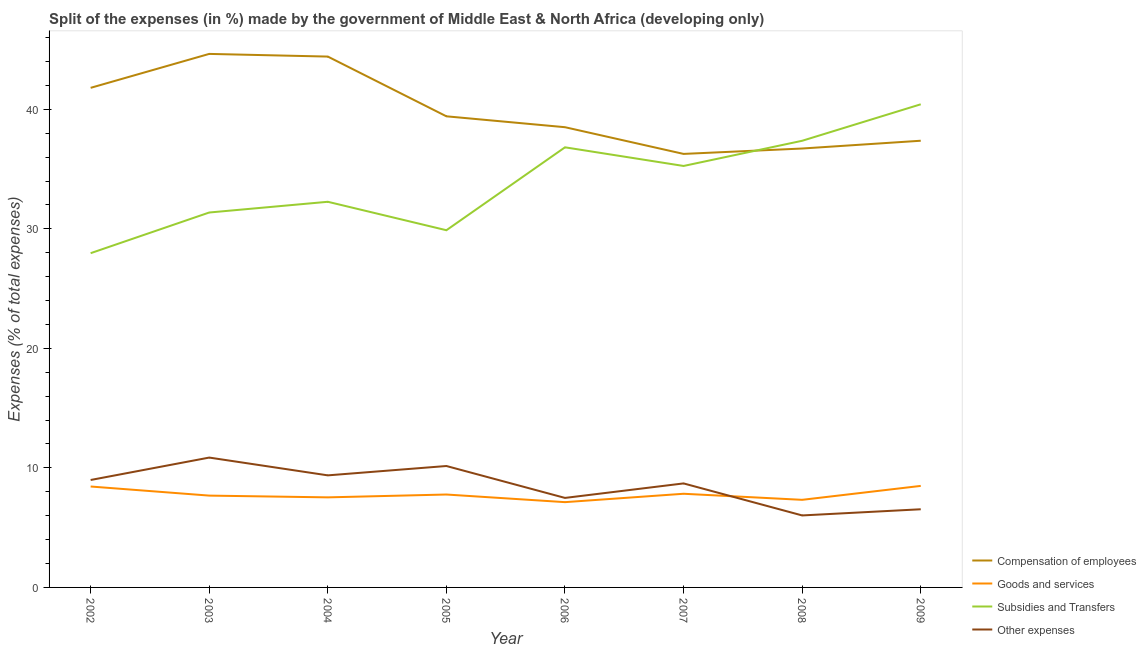Does the line corresponding to percentage of amount spent on goods and services intersect with the line corresponding to percentage of amount spent on subsidies?
Ensure brevity in your answer.  No. What is the percentage of amount spent on compensation of employees in 2006?
Your response must be concise. 38.5. Across all years, what is the maximum percentage of amount spent on other expenses?
Offer a very short reply. 10.86. Across all years, what is the minimum percentage of amount spent on other expenses?
Provide a succinct answer. 6.02. What is the total percentage of amount spent on goods and services in the graph?
Your answer should be compact. 62.23. What is the difference between the percentage of amount spent on goods and services in 2004 and that in 2009?
Give a very brief answer. -0.96. What is the difference between the percentage of amount spent on subsidies in 2002 and the percentage of amount spent on goods and services in 2005?
Make the answer very short. 20.19. What is the average percentage of amount spent on subsidies per year?
Make the answer very short. 33.92. In the year 2002, what is the difference between the percentage of amount spent on subsidies and percentage of amount spent on goods and services?
Provide a succinct answer. 19.52. What is the ratio of the percentage of amount spent on subsidies in 2007 to that in 2008?
Offer a very short reply. 0.94. Is the percentage of amount spent on goods and services in 2002 less than that in 2003?
Your answer should be compact. No. Is the difference between the percentage of amount spent on other expenses in 2002 and 2007 greater than the difference between the percentage of amount spent on subsidies in 2002 and 2007?
Ensure brevity in your answer.  Yes. What is the difference between the highest and the second highest percentage of amount spent on subsidies?
Ensure brevity in your answer.  3.05. What is the difference between the highest and the lowest percentage of amount spent on subsidies?
Provide a short and direct response. 12.46. Does the percentage of amount spent on compensation of employees monotonically increase over the years?
Ensure brevity in your answer.  No. Is the percentage of amount spent on other expenses strictly less than the percentage of amount spent on subsidies over the years?
Provide a succinct answer. Yes. How many lines are there?
Provide a succinct answer. 4. Where does the legend appear in the graph?
Keep it short and to the point. Bottom right. How many legend labels are there?
Offer a very short reply. 4. How are the legend labels stacked?
Give a very brief answer. Vertical. What is the title of the graph?
Provide a succinct answer. Split of the expenses (in %) made by the government of Middle East & North Africa (developing only). What is the label or title of the X-axis?
Give a very brief answer. Year. What is the label or title of the Y-axis?
Offer a terse response. Expenses (% of total expenses). What is the Expenses (% of total expenses) of Compensation of employees in 2002?
Your response must be concise. 41.8. What is the Expenses (% of total expenses) of Goods and services in 2002?
Offer a terse response. 8.44. What is the Expenses (% of total expenses) in Subsidies and Transfers in 2002?
Provide a short and direct response. 27.96. What is the Expenses (% of total expenses) in Other expenses in 2002?
Provide a short and direct response. 8.99. What is the Expenses (% of total expenses) of Compensation of employees in 2003?
Keep it short and to the point. 44.64. What is the Expenses (% of total expenses) in Goods and services in 2003?
Your answer should be compact. 7.68. What is the Expenses (% of total expenses) in Subsidies and Transfers in 2003?
Give a very brief answer. 31.37. What is the Expenses (% of total expenses) in Other expenses in 2003?
Your answer should be compact. 10.86. What is the Expenses (% of total expenses) of Compensation of employees in 2004?
Keep it short and to the point. 44.41. What is the Expenses (% of total expenses) of Goods and services in 2004?
Your response must be concise. 7.54. What is the Expenses (% of total expenses) of Subsidies and Transfers in 2004?
Provide a short and direct response. 32.26. What is the Expenses (% of total expenses) in Other expenses in 2004?
Give a very brief answer. 9.38. What is the Expenses (% of total expenses) of Compensation of employees in 2005?
Provide a succinct answer. 39.41. What is the Expenses (% of total expenses) of Goods and services in 2005?
Offer a very short reply. 7.77. What is the Expenses (% of total expenses) in Subsidies and Transfers in 2005?
Provide a short and direct response. 29.88. What is the Expenses (% of total expenses) in Other expenses in 2005?
Ensure brevity in your answer.  10.16. What is the Expenses (% of total expenses) in Compensation of employees in 2006?
Your answer should be compact. 38.5. What is the Expenses (% of total expenses) of Goods and services in 2006?
Make the answer very short. 7.13. What is the Expenses (% of total expenses) in Subsidies and Transfers in 2006?
Your answer should be very brief. 36.82. What is the Expenses (% of total expenses) of Other expenses in 2006?
Offer a very short reply. 7.49. What is the Expenses (% of total expenses) in Compensation of employees in 2007?
Keep it short and to the point. 36.27. What is the Expenses (% of total expenses) in Goods and services in 2007?
Your answer should be compact. 7.84. What is the Expenses (% of total expenses) of Subsidies and Transfers in 2007?
Your answer should be very brief. 35.26. What is the Expenses (% of total expenses) of Other expenses in 2007?
Your response must be concise. 8.7. What is the Expenses (% of total expenses) of Compensation of employees in 2008?
Make the answer very short. 36.72. What is the Expenses (% of total expenses) in Goods and services in 2008?
Your answer should be compact. 7.33. What is the Expenses (% of total expenses) of Subsidies and Transfers in 2008?
Provide a succinct answer. 37.37. What is the Expenses (% of total expenses) in Other expenses in 2008?
Your answer should be very brief. 6.02. What is the Expenses (% of total expenses) of Compensation of employees in 2009?
Offer a very short reply. 37.37. What is the Expenses (% of total expenses) of Goods and services in 2009?
Give a very brief answer. 8.49. What is the Expenses (% of total expenses) in Subsidies and Transfers in 2009?
Give a very brief answer. 40.42. What is the Expenses (% of total expenses) of Other expenses in 2009?
Your answer should be very brief. 6.54. Across all years, what is the maximum Expenses (% of total expenses) in Compensation of employees?
Your answer should be very brief. 44.64. Across all years, what is the maximum Expenses (% of total expenses) of Goods and services?
Make the answer very short. 8.49. Across all years, what is the maximum Expenses (% of total expenses) of Subsidies and Transfers?
Make the answer very short. 40.42. Across all years, what is the maximum Expenses (% of total expenses) in Other expenses?
Provide a short and direct response. 10.86. Across all years, what is the minimum Expenses (% of total expenses) in Compensation of employees?
Make the answer very short. 36.27. Across all years, what is the minimum Expenses (% of total expenses) of Goods and services?
Provide a short and direct response. 7.13. Across all years, what is the minimum Expenses (% of total expenses) in Subsidies and Transfers?
Give a very brief answer. 27.96. Across all years, what is the minimum Expenses (% of total expenses) of Other expenses?
Provide a succinct answer. 6.02. What is the total Expenses (% of total expenses) of Compensation of employees in the graph?
Provide a succinct answer. 319.13. What is the total Expenses (% of total expenses) of Goods and services in the graph?
Offer a terse response. 62.23. What is the total Expenses (% of total expenses) of Subsidies and Transfers in the graph?
Your answer should be very brief. 271.35. What is the total Expenses (% of total expenses) of Other expenses in the graph?
Offer a terse response. 68.14. What is the difference between the Expenses (% of total expenses) of Compensation of employees in 2002 and that in 2003?
Provide a short and direct response. -2.84. What is the difference between the Expenses (% of total expenses) in Goods and services in 2002 and that in 2003?
Your answer should be very brief. 0.76. What is the difference between the Expenses (% of total expenses) of Subsidies and Transfers in 2002 and that in 2003?
Give a very brief answer. -3.4. What is the difference between the Expenses (% of total expenses) of Other expenses in 2002 and that in 2003?
Provide a succinct answer. -1.87. What is the difference between the Expenses (% of total expenses) in Compensation of employees in 2002 and that in 2004?
Offer a very short reply. -2.62. What is the difference between the Expenses (% of total expenses) of Goods and services in 2002 and that in 2004?
Keep it short and to the point. 0.91. What is the difference between the Expenses (% of total expenses) of Subsidies and Transfers in 2002 and that in 2004?
Offer a terse response. -4.3. What is the difference between the Expenses (% of total expenses) in Other expenses in 2002 and that in 2004?
Give a very brief answer. -0.39. What is the difference between the Expenses (% of total expenses) in Compensation of employees in 2002 and that in 2005?
Your response must be concise. 2.38. What is the difference between the Expenses (% of total expenses) of Goods and services in 2002 and that in 2005?
Your answer should be very brief. 0.67. What is the difference between the Expenses (% of total expenses) in Subsidies and Transfers in 2002 and that in 2005?
Keep it short and to the point. -1.92. What is the difference between the Expenses (% of total expenses) of Other expenses in 2002 and that in 2005?
Your answer should be compact. -1.17. What is the difference between the Expenses (% of total expenses) in Compensation of employees in 2002 and that in 2006?
Ensure brevity in your answer.  3.29. What is the difference between the Expenses (% of total expenses) of Goods and services in 2002 and that in 2006?
Offer a very short reply. 1.31. What is the difference between the Expenses (% of total expenses) in Subsidies and Transfers in 2002 and that in 2006?
Offer a very short reply. -8.86. What is the difference between the Expenses (% of total expenses) of Other expenses in 2002 and that in 2006?
Your response must be concise. 1.5. What is the difference between the Expenses (% of total expenses) in Compensation of employees in 2002 and that in 2007?
Provide a succinct answer. 5.53. What is the difference between the Expenses (% of total expenses) in Goods and services in 2002 and that in 2007?
Your answer should be very brief. 0.61. What is the difference between the Expenses (% of total expenses) in Subsidies and Transfers in 2002 and that in 2007?
Your answer should be very brief. -7.3. What is the difference between the Expenses (% of total expenses) of Other expenses in 2002 and that in 2007?
Provide a short and direct response. 0.29. What is the difference between the Expenses (% of total expenses) of Compensation of employees in 2002 and that in 2008?
Provide a succinct answer. 5.08. What is the difference between the Expenses (% of total expenses) of Goods and services in 2002 and that in 2008?
Your answer should be very brief. 1.11. What is the difference between the Expenses (% of total expenses) of Subsidies and Transfers in 2002 and that in 2008?
Give a very brief answer. -9.4. What is the difference between the Expenses (% of total expenses) of Other expenses in 2002 and that in 2008?
Make the answer very short. 2.97. What is the difference between the Expenses (% of total expenses) in Compensation of employees in 2002 and that in 2009?
Your response must be concise. 4.43. What is the difference between the Expenses (% of total expenses) in Goods and services in 2002 and that in 2009?
Keep it short and to the point. -0.05. What is the difference between the Expenses (% of total expenses) in Subsidies and Transfers in 2002 and that in 2009?
Your response must be concise. -12.46. What is the difference between the Expenses (% of total expenses) in Other expenses in 2002 and that in 2009?
Your answer should be very brief. 2.45. What is the difference between the Expenses (% of total expenses) in Compensation of employees in 2003 and that in 2004?
Ensure brevity in your answer.  0.22. What is the difference between the Expenses (% of total expenses) of Goods and services in 2003 and that in 2004?
Ensure brevity in your answer.  0.15. What is the difference between the Expenses (% of total expenses) of Subsidies and Transfers in 2003 and that in 2004?
Offer a terse response. -0.9. What is the difference between the Expenses (% of total expenses) in Other expenses in 2003 and that in 2004?
Provide a short and direct response. 1.49. What is the difference between the Expenses (% of total expenses) of Compensation of employees in 2003 and that in 2005?
Offer a very short reply. 5.22. What is the difference between the Expenses (% of total expenses) in Goods and services in 2003 and that in 2005?
Your answer should be compact. -0.09. What is the difference between the Expenses (% of total expenses) in Subsidies and Transfers in 2003 and that in 2005?
Your answer should be compact. 1.48. What is the difference between the Expenses (% of total expenses) in Other expenses in 2003 and that in 2005?
Offer a terse response. 0.71. What is the difference between the Expenses (% of total expenses) of Compensation of employees in 2003 and that in 2006?
Your answer should be compact. 6.13. What is the difference between the Expenses (% of total expenses) of Goods and services in 2003 and that in 2006?
Provide a short and direct response. 0.55. What is the difference between the Expenses (% of total expenses) in Subsidies and Transfers in 2003 and that in 2006?
Your response must be concise. -5.45. What is the difference between the Expenses (% of total expenses) in Other expenses in 2003 and that in 2006?
Give a very brief answer. 3.38. What is the difference between the Expenses (% of total expenses) of Compensation of employees in 2003 and that in 2007?
Offer a very short reply. 8.37. What is the difference between the Expenses (% of total expenses) in Goods and services in 2003 and that in 2007?
Give a very brief answer. -0.15. What is the difference between the Expenses (% of total expenses) of Subsidies and Transfers in 2003 and that in 2007?
Offer a terse response. -3.89. What is the difference between the Expenses (% of total expenses) of Other expenses in 2003 and that in 2007?
Give a very brief answer. 2.16. What is the difference between the Expenses (% of total expenses) of Compensation of employees in 2003 and that in 2008?
Your answer should be very brief. 7.92. What is the difference between the Expenses (% of total expenses) in Goods and services in 2003 and that in 2008?
Make the answer very short. 0.35. What is the difference between the Expenses (% of total expenses) of Subsidies and Transfers in 2003 and that in 2008?
Give a very brief answer. -6. What is the difference between the Expenses (% of total expenses) in Other expenses in 2003 and that in 2008?
Keep it short and to the point. 4.84. What is the difference between the Expenses (% of total expenses) in Compensation of employees in 2003 and that in 2009?
Your answer should be compact. 7.26. What is the difference between the Expenses (% of total expenses) in Goods and services in 2003 and that in 2009?
Your answer should be very brief. -0.81. What is the difference between the Expenses (% of total expenses) of Subsidies and Transfers in 2003 and that in 2009?
Provide a short and direct response. -9.05. What is the difference between the Expenses (% of total expenses) of Other expenses in 2003 and that in 2009?
Provide a succinct answer. 4.33. What is the difference between the Expenses (% of total expenses) of Compensation of employees in 2004 and that in 2005?
Ensure brevity in your answer.  5. What is the difference between the Expenses (% of total expenses) of Goods and services in 2004 and that in 2005?
Offer a very short reply. -0.24. What is the difference between the Expenses (% of total expenses) of Subsidies and Transfers in 2004 and that in 2005?
Offer a terse response. 2.38. What is the difference between the Expenses (% of total expenses) in Other expenses in 2004 and that in 2005?
Your answer should be very brief. -0.78. What is the difference between the Expenses (% of total expenses) of Compensation of employees in 2004 and that in 2006?
Keep it short and to the point. 5.91. What is the difference between the Expenses (% of total expenses) of Goods and services in 2004 and that in 2006?
Keep it short and to the point. 0.4. What is the difference between the Expenses (% of total expenses) in Subsidies and Transfers in 2004 and that in 2006?
Provide a succinct answer. -4.56. What is the difference between the Expenses (% of total expenses) of Other expenses in 2004 and that in 2006?
Offer a very short reply. 1.89. What is the difference between the Expenses (% of total expenses) in Compensation of employees in 2004 and that in 2007?
Offer a very short reply. 8.14. What is the difference between the Expenses (% of total expenses) in Goods and services in 2004 and that in 2007?
Make the answer very short. -0.3. What is the difference between the Expenses (% of total expenses) in Subsidies and Transfers in 2004 and that in 2007?
Provide a succinct answer. -3. What is the difference between the Expenses (% of total expenses) in Other expenses in 2004 and that in 2007?
Your answer should be compact. 0.67. What is the difference between the Expenses (% of total expenses) in Compensation of employees in 2004 and that in 2008?
Provide a succinct answer. 7.69. What is the difference between the Expenses (% of total expenses) in Goods and services in 2004 and that in 2008?
Provide a succinct answer. 0.21. What is the difference between the Expenses (% of total expenses) of Subsidies and Transfers in 2004 and that in 2008?
Provide a short and direct response. -5.1. What is the difference between the Expenses (% of total expenses) of Other expenses in 2004 and that in 2008?
Your answer should be very brief. 3.35. What is the difference between the Expenses (% of total expenses) of Compensation of employees in 2004 and that in 2009?
Your answer should be very brief. 7.04. What is the difference between the Expenses (% of total expenses) of Goods and services in 2004 and that in 2009?
Your response must be concise. -0.96. What is the difference between the Expenses (% of total expenses) in Subsidies and Transfers in 2004 and that in 2009?
Provide a short and direct response. -8.16. What is the difference between the Expenses (% of total expenses) in Other expenses in 2004 and that in 2009?
Offer a terse response. 2.84. What is the difference between the Expenses (% of total expenses) in Compensation of employees in 2005 and that in 2006?
Give a very brief answer. 0.91. What is the difference between the Expenses (% of total expenses) of Goods and services in 2005 and that in 2006?
Your answer should be compact. 0.64. What is the difference between the Expenses (% of total expenses) in Subsidies and Transfers in 2005 and that in 2006?
Provide a short and direct response. -6.94. What is the difference between the Expenses (% of total expenses) in Other expenses in 2005 and that in 2006?
Provide a short and direct response. 2.67. What is the difference between the Expenses (% of total expenses) in Compensation of employees in 2005 and that in 2007?
Offer a very short reply. 3.15. What is the difference between the Expenses (% of total expenses) in Goods and services in 2005 and that in 2007?
Provide a succinct answer. -0.06. What is the difference between the Expenses (% of total expenses) in Subsidies and Transfers in 2005 and that in 2007?
Make the answer very short. -5.38. What is the difference between the Expenses (% of total expenses) in Other expenses in 2005 and that in 2007?
Your answer should be very brief. 1.46. What is the difference between the Expenses (% of total expenses) in Compensation of employees in 2005 and that in 2008?
Ensure brevity in your answer.  2.69. What is the difference between the Expenses (% of total expenses) in Goods and services in 2005 and that in 2008?
Ensure brevity in your answer.  0.44. What is the difference between the Expenses (% of total expenses) of Subsidies and Transfers in 2005 and that in 2008?
Make the answer very short. -7.48. What is the difference between the Expenses (% of total expenses) in Other expenses in 2005 and that in 2008?
Provide a short and direct response. 4.14. What is the difference between the Expenses (% of total expenses) in Compensation of employees in 2005 and that in 2009?
Your response must be concise. 2.04. What is the difference between the Expenses (% of total expenses) in Goods and services in 2005 and that in 2009?
Your response must be concise. -0.72. What is the difference between the Expenses (% of total expenses) in Subsidies and Transfers in 2005 and that in 2009?
Your answer should be compact. -10.54. What is the difference between the Expenses (% of total expenses) of Other expenses in 2005 and that in 2009?
Provide a succinct answer. 3.62. What is the difference between the Expenses (% of total expenses) of Compensation of employees in 2006 and that in 2007?
Provide a succinct answer. 2.23. What is the difference between the Expenses (% of total expenses) in Goods and services in 2006 and that in 2007?
Provide a short and direct response. -0.7. What is the difference between the Expenses (% of total expenses) in Subsidies and Transfers in 2006 and that in 2007?
Ensure brevity in your answer.  1.56. What is the difference between the Expenses (% of total expenses) in Other expenses in 2006 and that in 2007?
Offer a very short reply. -1.21. What is the difference between the Expenses (% of total expenses) in Compensation of employees in 2006 and that in 2008?
Your answer should be compact. 1.78. What is the difference between the Expenses (% of total expenses) of Goods and services in 2006 and that in 2008?
Your answer should be very brief. -0.19. What is the difference between the Expenses (% of total expenses) of Subsidies and Transfers in 2006 and that in 2008?
Offer a terse response. -0.55. What is the difference between the Expenses (% of total expenses) in Other expenses in 2006 and that in 2008?
Ensure brevity in your answer.  1.47. What is the difference between the Expenses (% of total expenses) in Compensation of employees in 2006 and that in 2009?
Your answer should be very brief. 1.13. What is the difference between the Expenses (% of total expenses) in Goods and services in 2006 and that in 2009?
Offer a very short reply. -1.36. What is the difference between the Expenses (% of total expenses) of Subsidies and Transfers in 2006 and that in 2009?
Give a very brief answer. -3.6. What is the difference between the Expenses (% of total expenses) of Other expenses in 2006 and that in 2009?
Provide a short and direct response. 0.95. What is the difference between the Expenses (% of total expenses) in Compensation of employees in 2007 and that in 2008?
Provide a succinct answer. -0.45. What is the difference between the Expenses (% of total expenses) of Goods and services in 2007 and that in 2008?
Make the answer very short. 0.51. What is the difference between the Expenses (% of total expenses) in Subsidies and Transfers in 2007 and that in 2008?
Give a very brief answer. -2.11. What is the difference between the Expenses (% of total expenses) of Other expenses in 2007 and that in 2008?
Provide a short and direct response. 2.68. What is the difference between the Expenses (% of total expenses) of Compensation of employees in 2007 and that in 2009?
Offer a terse response. -1.1. What is the difference between the Expenses (% of total expenses) of Goods and services in 2007 and that in 2009?
Provide a succinct answer. -0.66. What is the difference between the Expenses (% of total expenses) of Subsidies and Transfers in 2007 and that in 2009?
Provide a short and direct response. -5.16. What is the difference between the Expenses (% of total expenses) of Other expenses in 2007 and that in 2009?
Offer a terse response. 2.16. What is the difference between the Expenses (% of total expenses) in Compensation of employees in 2008 and that in 2009?
Offer a very short reply. -0.65. What is the difference between the Expenses (% of total expenses) of Goods and services in 2008 and that in 2009?
Your answer should be compact. -1.17. What is the difference between the Expenses (% of total expenses) of Subsidies and Transfers in 2008 and that in 2009?
Keep it short and to the point. -3.05. What is the difference between the Expenses (% of total expenses) of Other expenses in 2008 and that in 2009?
Ensure brevity in your answer.  -0.52. What is the difference between the Expenses (% of total expenses) of Compensation of employees in 2002 and the Expenses (% of total expenses) of Goods and services in 2003?
Your answer should be very brief. 34.12. What is the difference between the Expenses (% of total expenses) in Compensation of employees in 2002 and the Expenses (% of total expenses) in Subsidies and Transfers in 2003?
Offer a terse response. 10.43. What is the difference between the Expenses (% of total expenses) of Compensation of employees in 2002 and the Expenses (% of total expenses) of Other expenses in 2003?
Ensure brevity in your answer.  30.93. What is the difference between the Expenses (% of total expenses) in Goods and services in 2002 and the Expenses (% of total expenses) in Subsidies and Transfers in 2003?
Your answer should be very brief. -22.92. What is the difference between the Expenses (% of total expenses) of Goods and services in 2002 and the Expenses (% of total expenses) of Other expenses in 2003?
Your answer should be very brief. -2.42. What is the difference between the Expenses (% of total expenses) of Subsidies and Transfers in 2002 and the Expenses (% of total expenses) of Other expenses in 2003?
Keep it short and to the point. 17.1. What is the difference between the Expenses (% of total expenses) of Compensation of employees in 2002 and the Expenses (% of total expenses) of Goods and services in 2004?
Provide a short and direct response. 34.26. What is the difference between the Expenses (% of total expenses) in Compensation of employees in 2002 and the Expenses (% of total expenses) in Subsidies and Transfers in 2004?
Your answer should be compact. 9.53. What is the difference between the Expenses (% of total expenses) in Compensation of employees in 2002 and the Expenses (% of total expenses) in Other expenses in 2004?
Offer a very short reply. 32.42. What is the difference between the Expenses (% of total expenses) of Goods and services in 2002 and the Expenses (% of total expenses) of Subsidies and Transfers in 2004?
Make the answer very short. -23.82. What is the difference between the Expenses (% of total expenses) in Goods and services in 2002 and the Expenses (% of total expenses) in Other expenses in 2004?
Provide a succinct answer. -0.93. What is the difference between the Expenses (% of total expenses) of Subsidies and Transfers in 2002 and the Expenses (% of total expenses) of Other expenses in 2004?
Your answer should be compact. 18.59. What is the difference between the Expenses (% of total expenses) of Compensation of employees in 2002 and the Expenses (% of total expenses) of Goods and services in 2005?
Provide a short and direct response. 34.02. What is the difference between the Expenses (% of total expenses) of Compensation of employees in 2002 and the Expenses (% of total expenses) of Subsidies and Transfers in 2005?
Ensure brevity in your answer.  11.91. What is the difference between the Expenses (% of total expenses) in Compensation of employees in 2002 and the Expenses (% of total expenses) in Other expenses in 2005?
Your answer should be compact. 31.64. What is the difference between the Expenses (% of total expenses) of Goods and services in 2002 and the Expenses (% of total expenses) of Subsidies and Transfers in 2005?
Give a very brief answer. -21.44. What is the difference between the Expenses (% of total expenses) in Goods and services in 2002 and the Expenses (% of total expenses) in Other expenses in 2005?
Ensure brevity in your answer.  -1.72. What is the difference between the Expenses (% of total expenses) of Subsidies and Transfers in 2002 and the Expenses (% of total expenses) of Other expenses in 2005?
Ensure brevity in your answer.  17.81. What is the difference between the Expenses (% of total expenses) in Compensation of employees in 2002 and the Expenses (% of total expenses) in Goods and services in 2006?
Provide a succinct answer. 34.66. What is the difference between the Expenses (% of total expenses) of Compensation of employees in 2002 and the Expenses (% of total expenses) of Subsidies and Transfers in 2006?
Provide a short and direct response. 4.98. What is the difference between the Expenses (% of total expenses) in Compensation of employees in 2002 and the Expenses (% of total expenses) in Other expenses in 2006?
Provide a succinct answer. 34.31. What is the difference between the Expenses (% of total expenses) in Goods and services in 2002 and the Expenses (% of total expenses) in Subsidies and Transfers in 2006?
Offer a very short reply. -28.38. What is the difference between the Expenses (% of total expenses) of Goods and services in 2002 and the Expenses (% of total expenses) of Other expenses in 2006?
Offer a very short reply. 0.95. What is the difference between the Expenses (% of total expenses) in Subsidies and Transfers in 2002 and the Expenses (% of total expenses) in Other expenses in 2006?
Keep it short and to the point. 20.48. What is the difference between the Expenses (% of total expenses) in Compensation of employees in 2002 and the Expenses (% of total expenses) in Goods and services in 2007?
Ensure brevity in your answer.  33.96. What is the difference between the Expenses (% of total expenses) in Compensation of employees in 2002 and the Expenses (% of total expenses) in Subsidies and Transfers in 2007?
Offer a very short reply. 6.54. What is the difference between the Expenses (% of total expenses) of Compensation of employees in 2002 and the Expenses (% of total expenses) of Other expenses in 2007?
Your answer should be compact. 33.1. What is the difference between the Expenses (% of total expenses) in Goods and services in 2002 and the Expenses (% of total expenses) in Subsidies and Transfers in 2007?
Keep it short and to the point. -26.82. What is the difference between the Expenses (% of total expenses) of Goods and services in 2002 and the Expenses (% of total expenses) of Other expenses in 2007?
Provide a short and direct response. -0.26. What is the difference between the Expenses (% of total expenses) in Subsidies and Transfers in 2002 and the Expenses (% of total expenses) in Other expenses in 2007?
Your answer should be compact. 19.26. What is the difference between the Expenses (% of total expenses) of Compensation of employees in 2002 and the Expenses (% of total expenses) of Goods and services in 2008?
Make the answer very short. 34.47. What is the difference between the Expenses (% of total expenses) of Compensation of employees in 2002 and the Expenses (% of total expenses) of Subsidies and Transfers in 2008?
Provide a short and direct response. 4.43. What is the difference between the Expenses (% of total expenses) of Compensation of employees in 2002 and the Expenses (% of total expenses) of Other expenses in 2008?
Keep it short and to the point. 35.78. What is the difference between the Expenses (% of total expenses) in Goods and services in 2002 and the Expenses (% of total expenses) in Subsidies and Transfers in 2008?
Keep it short and to the point. -28.93. What is the difference between the Expenses (% of total expenses) in Goods and services in 2002 and the Expenses (% of total expenses) in Other expenses in 2008?
Make the answer very short. 2.42. What is the difference between the Expenses (% of total expenses) in Subsidies and Transfers in 2002 and the Expenses (% of total expenses) in Other expenses in 2008?
Keep it short and to the point. 21.94. What is the difference between the Expenses (% of total expenses) of Compensation of employees in 2002 and the Expenses (% of total expenses) of Goods and services in 2009?
Your answer should be compact. 33.3. What is the difference between the Expenses (% of total expenses) of Compensation of employees in 2002 and the Expenses (% of total expenses) of Subsidies and Transfers in 2009?
Offer a terse response. 1.38. What is the difference between the Expenses (% of total expenses) of Compensation of employees in 2002 and the Expenses (% of total expenses) of Other expenses in 2009?
Your response must be concise. 35.26. What is the difference between the Expenses (% of total expenses) in Goods and services in 2002 and the Expenses (% of total expenses) in Subsidies and Transfers in 2009?
Provide a succinct answer. -31.98. What is the difference between the Expenses (% of total expenses) of Goods and services in 2002 and the Expenses (% of total expenses) of Other expenses in 2009?
Provide a short and direct response. 1.9. What is the difference between the Expenses (% of total expenses) of Subsidies and Transfers in 2002 and the Expenses (% of total expenses) of Other expenses in 2009?
Make the answer very short. 21.43. What is the difference between the Expenses (% of total expenses) in Compensation of employees in 2003 and the Expenses (% of total expenses) in Goods and services in 2004?
Offer a terse response. 37.1. What is the difference between the Expenses (% of total expenses) in Compensation of employees in 2003 and the Expenses (% of total expenses) in Subsidies and Transfers in 2004?
Your response must be concise. 12.37. What is the difference between the Expenses (% of total expenses) of Compensation of employees in 2003 and the Expenses (% of total expenses) of Other expenses in 2004?
Keep it short and to the point. 35.26. What is the difference between the Expenses (% of total expenses) in Goods and services in 2003 and the Expenses (% of total expenses) in Subsidies and Transfers in 2004?
Offer a very short reply. -24.58. What is the difference between the Expenses (% of total expenses) in Goods and services in 2003 and the Expenses (% of total expenses) in Other expenses in 2004?
Offer a very short reply. -1.69. What is the difference between the Expenses (% of total expenses) in Subsidies and Transfers in 2003 and the Expenses (% of total expenses) in Other expenses in 2004?
Keep it short and to the point. 21.99. What is the difference between the Expenses (% of total expenses) in Compensation of employees in 2003 and the Expenses (% of total expenses) in Goods and services in 2005?
Make the answer very short. 36.86. What is the difference between the Expenses (% of total expenses) in Compensation of employees in 2003 and the Expenses (% of total expenses) in Subsidies and Transfers in 2005?
Give a very brief answer. 14.75. What is the difference between the Expenses (% of total expenses) of Compensation of employees in 2003 and the Expenses (% of total expenses) of Other expenses in 2005?
Keep it short and to the point. 34.48. What is the difference between the Expenses (% of total expenses) in Goods and services in 2003 and the Expenses (% of total expenses) in Subsidies and Transfers in 2005?
Your answer should be compact. -22.2. What is the difference between the Expenses (% of total expenses) of Goods and services in 2003 and the Expenses (% of total expenses) of Other expenses in 2005?
Your answer should be compact. -2.48. What is the difference between the Expenses (% of total expenses) of Subsidies and Transfers in 2003 and the Expenses (% of total expenses) of Other expenses in 2005?
Offer a very short reply. 21.21. What is the difference between the Expenses (% of total expenses) in Compensation of employees in 2003 and the Expenses (% of total expenses) in Goods and services in 2006?
Offer a very short reply. 37.5. What is the difference between the Expenses (% of total expenses) of Compensation of employees in 2003 and the Expenses (% of total expenses) of Subsidies and Transfers in 2006?
Offer a very short reply. 7.82. What is the difference between the Expenses (% of total expenses) in Compensation of employees in 2003 and the Expenses (% of total expenses) in Other expenses in 2006?
Your answer should be compact. 37.15. What is the difference between the Expenses (% of total expenses) of Goods and services in 2003 and the Expenses (% of total expenses) of Subsidies and Transfers in 2006?
Give a very brief answer. -29.14. What is the difference between the Expenses (% of total expenses) of Goods and services in 2003 and the Expenses (% of total expenses) of Other expenses in 2006?
Your answer should be compact. 0.19. What is the difference between the Expenses (% of total expenses) of Subsidies and Transfers in 2003 and the Expenses (% of total expenses) of Other expenses in 2006?
Your answer should be very brief. 23.88. What is the difference between the Expenses (% of total expenses) in Compensation of employees in 2003 and the Expenses (% of total expenses) in Goods and services in 2007?
Your answer should be very brief. 36.8. What is the difference between the Expenses (% of total expenses) in Compensation of employees in 2003 and the Expenses (% of total expenses) in Subsidies and Transfers in 2007?
Your response must be concise. 9.38. What is the difference between the Expenses (% of total expenses) of Compensation of employees in 2003 and the Expenses (% of total expenses) of Other expenses in 2007?
Give a very brief answer. 35.93. What is the difference between the Expenses (% of total expenses) in Goods and services in 2003 and the Expenses (% of total expenses) in Subsidies and Transfers in 2007?
Your answer should be compact. -27.58. What is the difference between the Expenses (% of total expenses) of Goods and services in 2003 and the Expenses (% of total expenses) of Other expenses in 2007?
Offer a terse response. -1.02. What is the difference between the Expenses (% of total expenses) in Subsidies and Transfers in 2003 and the Expenses (% of total expenses) in Other expenses in 2007?
Provide a short and direct response. 22.67. What is the difference between the Expenses (% of total expenses) of Compensation of employees in 2003 and the Expenses (% of total expenses) of Goods and services in 2008?
Keep it short and to the point. 37.31. What is the difference between the Expenses (% of total expenses) of Compensation of employees in 2003 and the Expenses (% of total expenses) of Subsidies and Transfers in 2008?
Make the answer very short. 7.27. What is the difference between the Expenses (% of total expenses) in Compensation of employees in 2003 and the Expenses (% of total expenses) in Other expenses in 2008?
Offer a very short reply. 38.61. What is the difference between the Expenses (% of total expenses) of Goods and services in 2003 and the Expenses (% of total expenses) of Subsidies and Transfers in 2008?
Provide a succinct answer. -29.69. What is the difference between the Expenses (% of total expenses) in Goods and services in 2003 and the Expenses (% of total expenses) in Other expenses in 2008?
Your response must be concise. 1.66. What is the difference between the Expenses (% of total expenses) of Subsidies and Transfers in 2003 and the Expenses (% of total expenses) of Other expenses in 2008?
Your response must be concise. 25.34. What is the difference between the Expenses (% of total expenses) in Compensation of employees in 2003 and the Expenses (% of total expenses) in Goods and services in 2009?
Make the answer very short. 36.14. What is the difference between the Expenses (% of total expenses) of Compensation of employees in 2003 and the Expenses (% of total expenses) of Subsidies and Transfers in 2009?
Your answer should be very brief. 4.22. What is the difference between the Expenses (% of total expenses) of Compensation of employees in 2003 and the Expenses (% of total expenses) of Other expenses in 2009?
Your answer should be very brief. 38.1. What is the difference between the Expenses (% of total expenses) of Goods and services in 2003 and the Expenses (% of total expenses) of Subsidies and Transfers in 2009?
Your answer should be compact. -32.74. What is the difference between the Expenses (% of total expenses) in Goods and services in 2003 and the Expenses (% of total expenses) in Other expenses in 2009?
Make the answer very short. 1.14. What is the difference between the Expenses (% of total expenses) in Subsidies and Transfers in 2003 and the Expenses (% of total expenses) in Other expenses in 2009?
Make the answer very short. 24.83. What is the difference between the Expenses (% of total expenses) of Compensation of employees in 2004 and the Expenses (% of total expenses) of Goods and services in 2005?
Offer a terse response. 36.64. What is the difference between the Expenses (% of total expenses) of Compensation of employees in 2004 and the Expenses (% of total expenses) of Subsidies and Transfers in 2005?
Keep it short and to the point. 14.53. What is the difference between the Expenses (% of total expenses) in Compensation of employees in 2004 and the Expenses (% of total expenses) in Other expenses in 2005?
Your answer should be very brief. 34.25. What is the difference between the Expenses (% of total expenses) in Goods and services in 2004 and the Expenses (% of total expenses) in Subsidies and Transfers in 2005?
Ensure brevity in your answer.  -22.35. What is the difference between the Expenses (% of total expenses) in Goods and services in 2004 and the Expenses (% of total expenses) in Other expenses in 2005?
Provide a succinct answer. -2.62. What is the difference between the Expenses (% of total expenses) of Subsidies and Transfers in 2004 and the Expenses (% of total expenses) of Other expenses in 2005?
Keep it short and to the point. 22.11. What is the difference between the Expenses (% of total expenses) in Compensation of employees in 2004 and the Expenses (% of total expenses) in Goods and services in 2006?
Give a very brief answer. 37.28. What is the difference between the Expenses (% of total expenses) in Compensation of employees in 2004 and the Expenses (% of total expenses) in Subsidies and Transfers in 2006?
Provide a succinct answer. 7.59. What is the difference between the Expenses (% of total expenses) in Compensation of employees in 2004 and the Expenses (% of total expenses) in Other expenses in 2006?
Offer a terse response. 36.92. What is the difference between the Expenses (% of total expenses) of Goods and services in 2004 and the Expenses (% of total expenses) of Subsidies and Transfers in 2006?
Provide a succinct answer. -29.28. What is the difference between the Expenses (% of total expenses) of Goods and services in 2004 and the Expenses (% of total expenses) of Other expenses in 2006?
Your answer should be compact. 0.05. What is the difference between the Expenses (% of total expenses) of Subsidies and Transfers in 2004 and the Expenses (% of total expenses) of Other expenses in 2006?
Make the answer very short. 24.78. What is the difference between the Expenses (% of total expenses) in Compensation of employees in 2004 and the Expenses (% of total expenses) in Goods and services in 2007?
Offer a terse response. 36.58. What is the difference between the Expenses (% of total expenses) of Compensation of employees in 2004 and the Expenses (% of total expenses) of Subsidies and Transfers in 2007?
Provide a succinct answer. 9.15. What is the difference between the Expenses (% of total expenses) of Compensation of employees in 2004 and the Expenses (% of total expenses) of Other expenses in 2007?
Offer a very short reply. 35.71. What is the difference between the Expenses (% of total expenses) of Goods and services in 2004 and the Expenses (% of total expenses) of Subsidies and Transfers in 2007?
Make the answer very short. -27.73. What is the difference between the Expenses (% of total expenses) in Goods and services in 2004 and the Expenses (% of total expenses) in Other expenses in 2007?
Your response must be concise. -1.17. What is the difference between the Expenses (% of total expenses) of Subsidies and Transfers in 2004 and the Expenses (% of total expenses) of Other expenses in 2007?
Offer a terse response. 23.56. What is the difference between the Expenses (% of total expenses) of Compensation of employees in 2004 and the Expenses (% of total expenses) of Goods and services in 2008?
Provide a short and direct response. 37.08. What is the difference between the Expenses (% of total expenses) in Compensation of employees in 2004 and the Expenses (% of total expenses) in Subsidies and Transfers in 2008?
Your answer should be compact. 7.04. What is the difference between the Expenses (% of total expenses) in Compensation of employees in 2004 and the Expenses (% of total expenses) in Other expenses in 2008?
Offer a very short reply. 38.39. What is the difference between the Expenses (% of total expenses) of Goods and services in 2004 and the Expenses (% of total expenses) of Subsidies and Transfers in 2008?
Keep it short and to the point. -29.83. What is the difference between the Expenses (% of total expenses) of Goods and services in 2004 and the Expenses (% of total expenses) of Other expenses in 2008?
Provide a short and direct response. 1.51. What is the difference between the Expenses (% of total expenses) in Subsidies and Transfers in 2004 and the Expenses (% of total expenses) in Other expenses in 2008?
Your answer should be compact. 26.24. What is the difference between the Expenses (% of total expenses) of Compensation of employees in 2004 and the Expenses (% of total expenses) of Goods and services in 2009?
Provide a short and direct response. 35.92. What is the difference between the Expenses (% of total expenses) of Compensation of employees in 2004 and the Expenses (% of total expenses) of Subsidies and Transfers in 2009?
Your response must be concise. 3.99. What is the difference between the Expenses (% of total expenses) in Compensation of employees in 2004 and the Expenses (% of total expenses) in Other expenses in 2009?
Give a very brief answer. 37.87. What is the difference between the Expenses (% of total expenses) in Goods and services in 2004 and the Expenses (% of total expenses) in Subsidies and Transfers in 2009?
Offer a very short reply. -32.88. What is the difference between the Expenses (% of total expenses) in Goods and services in 2004 and the Expenses (% of total expenses) in Other expenses in 2009?
Your answer should be very brief. 1. What is the difference between the Expenses (% of total expenses) of Subsidies and Transfers in 2004 and the Expenses (% of total expenses) of Other expenses in 2009?
Provide a short and direct response. 25.73. What is the difference between the Expenses (% of total expenses) in Compensation of employees in 2005 and the Expenses (% of total expenses) in Goods and services in 2006?
Your answer should be compact. 32.28. What is the difference between the Expenses (% of total expenses) in Compensation of employees in 2005 and the Expenses (% of total expenses) in Subsidies and Transfers in 2006?
Provide a short and direct response. 2.59. What is the difference between the Expenses (% of total expenses) of Compensation of employees in 2005 and the Expenses (% of total expenses) of Other expenses in 2006?
Give a very brief answer. 31.93. What is the difference between the Expenses (% of total expenses) in Goods and services in 2005 and the Expenses (% of total expenses) in Subsidies and Transfers in 2006?
Provide a succinct answer. -29.05. What is the difference between the Expenses (% of total expenses) in Goods and services in 2005 and the Expenses (% of total expenses) in Other expenses in 2006?
Your answer should be compact. 0.28. What is the difference between the Expenses (% of total expenses) in Subsidies and Transfers in 2005 and the Expenses (% of total expenses) in Other expenses in 2006?
Your answer should be compact. 22.4. What is the difference between the Expenses (% of total expenses) in Compensation of employees in 2005 and the Expenses (% of total expenses) in Goods and services in 2007?
Your response must be concise. 31.58. What is the difference between the Expenses (% of total expenses) in Compensation of employees in 2005 and the Expenses (% of total expenses) in Subsidies and Transfers in 2007?
Offer a very short reply. 4.15. What is the difference between the Expenses (% of total expenses) in Compensation of employees in 2005 and the Expenses (% of total expenses) in Other expenses in 2007?
Provide a succinct answer. 30.71. What is the difference between the Expenses (% of total expenses) in Goods and services in 2005 and the Expenses (% of total expenses) in Subsidies and Transfers in 2007?
Offer a terse response. -27.49. What is the difference between the Expenses (% of total expenses) of Goods and services in 2005 and the Expenses (% of total expenses) of Other expenses in 2007?
Give a very brief answer. -0.93. What is the difference between the Expenses (% of total expenses) in Subsidies and Transfers in 2005 and the Expenses (% of total expenses) in Other expenses in 2007?
Provide a short and direct response. 21.18. What is the difference between the Expenses (% of total expenses) in Compensation of employees in 2005 and the Expenses (% of total expenses) in Goods and services in 2008?
Offer a very short reply. 32.09. What is the difference between the Expenses (% of total expenses) of Compensation of employees in 2005 and the Expenses (% of total expenses) of Subsidies and Transfers in 2008?
Make the answer very short. 2.05. What is the difference between the Expenses (% of total expenses) in Compensation of employees in 2005 and the Expenses (% of total expenses) in Other expenses in 2008?
Make the answer very short. 33.39. What is the difference between the Expenses (% of total expenses) in Goods and services in 2005 and the Expenses (% of total expenses) in Subsidies and Transfers in 2008?
Your answer should be very brief. -29.6. What is the difference between the Expenses (% of total expenses) in Goods and services in 2005 and the Expenses (% of total expenses) in Other expenses in 2008?
Offer a very short reply. 1.75. What is the difference between the Expenses (% of total expenses) in Subsidies and Transfers in 2005 and the Expenses (% of total expenses) in Other expenses in 2008?
Your answer should be compact. 23.86. What is the difference between the Expenses (% of total expenses) of Compensation of employees in 2005 and the Expenses (% of total expenses) of Goods and services in 2009?
Keep it short and to the point. 30.92. What is the difference between the Expenses (% of total expenses) in Compensation of employees in 2005 and the Expenses (% of total expenses) in Subsidies and Transfers in 2009?
Keep it short and to the point. -1.01. What is the difference between the Expenses (% of total expenses) in Compensation of employees in 2005 and the Expenses (% of total expenses) in Other expenses in 2009?
Provide a short and direct response. 32.88. What is the difference between the Expenses (% of total expenses) in Goods and services in 2005 and the Expenses (% of total expenses) in Subsidies and Transfers in 2009?
Provide a succinct answer. -32.65. What is the difference between the Expenses (% of total expenses) in Goods and services in 2005 and the Expenses (% of total expenses) in Other expenses in 2009?
Provide a succinct answer. 1.23. What is the difference between the Expenses (% of total expenses) in Subsidies and Transfers in 2005 and the Expenses (% of total expenses) in Other expenses in 2009?
Give a very brief answer. 23.35. What is the difference between the Expenses (% of total expenses) of Compensation of employees in 2006 and the Expenses (% of total expenses) of Goods and services in 2007?
Provide a short and direct response. 30.67. What is the difference between the Expenses (% of total expenses) of Compensation of employees in 2006 and the Expenses (% of total expenses) of Subsidies and Transfers in 2007?
Your answer should be compact. 3.24. What is the difference between the Expenses (% of total expenses) of Compensation of employees in 2006 and the Expenses (% of total expenses) of Other expenses in 2007?
Give a very brief answer. 29.8. What is the difference between the Expenses (% of total expenses) in Goods and services in 2006 and the Expenses (% of total expenses) in Subsidies and Transfers in 2007?
Provide a succinct answer. -28.13. What is the difference between the Expenses (% of total expenses) of Goods and services in 2006 and the Expenses (% of total expenses) of Other expenses in 2007?
Your answer should be compact. -1.57. What is the difference between the Expenses (% of total expenses) in Subsidies and Transfers in 2006 and the Expenses (% of total expenses) in Other expenses in 2007?
Give a very brief answer. 28.12. What is the difference between the Expenses (% of total expenses) in Compensation of employees in 2006 and the Expenses (% of total expenses) in Goods and services in 2008?
Give a very brief answer. 31.17. What is the difference between the Expenses (% of total expenses) in Compensation of employees in 2006 and the Expenses (% of total expenses) in Subsidies and Transfers in 2008?
Your answer should be very brief. 1.14. What is the difference between the Expenses (% of total expenses) in Compensation of employees in 2006 and the Expenses (% of total expenses) in Other expenses in 2008?
Give a very brief answer. 32.48. What is the difference between the Expenses (% of total expenses) of Goods and services in 2006 and the Expenses (% of total expenses) of Subsidies and Transfers in 2008?
Provide a succinct answer. -30.23. What is the difference between the Expenses (% of total expenses) of Goods and services in 2006 and the Expenses (% of total expenses) of Other expenses in 2008?
Provide a succinct answer. 1.11. What is the difference between the Expenses (% of total expenses) in Subsidies and Transfers in 2006 and the Expenses (% of total expenses) in Other expenses in 2008?
Provide a short and direct response. 30.8. What is the difference between the Expenses (% of total expenses) of Compensation of employees in 2006 and the Expenses (% of total expenses) of Goods and services in 2009?
Keep it short and to the point. 30.01. What is the difference between the Expenses (% of total expenses) of Compensation of employees in 2006 and the Expenses (% of total expenses) of Subsidies and Transfers in 2009?
Ensure brevity in your answer.  -1.92. What is the difference between the Expenses (% of total expenses) in Compensation of employees in 2006 and the Expenses (% of total expenses) in Other expenses in 2009?
Keep it short and to the point. 31.96. What is the difference between the Expenses (% of total expenses) in Goods and services in 2006 and the Expenses (% of total expenses) in Subsidies and Transfers in 2009?
Give a very brief answer. -33.29. What is the difference between the Expenses (% of total expenses) in Goods and services in 2006 and the Expenses (% of total expenses) in Other expenses in 2009?
Make the answer very short. 0.6. What is the difference between the Expenses (% of total expenses) in Subsidies and Transfers in 2006 and the Expenses (% of total expenses) in Other expenses in 2009?
Ensure brevity in your answer.  30.28. What is the difference between the Expenses (% of total expenses) in Compensation of employees in 2007 and the Expenses (% of total expenses) in Goods and services in 2008?
Keep it short and to the point. 28.94. What is the difference between the Expenses (% of total expenses) of Compensation of employees in 2007 and the Expenses (% of total expenses) of Subsidies and Transfers in 2008?
Make the answer very short. -1.1. What is the difference between the Expenses (% of total expenses) of Compensation of employees in 2007 and the Expenses (% of total expenses) of Other expenses in 2008?
Your response must be concise. 30.25. What is the difference between the Expenses (% of total expenses) in Goods and services in 2007 and the Expenses (% of total expenses) in Subsidies and Transfers in 2008?
Ensure brevity in your answer.  -29.53. What is the difference between the Expenses (% of total expenses) of Goods and services in 2007 and the Expenses (% of total expenses) of Other expenses in 2008?
Provide a succinct answer. 1.81. What is the difference between the Expenses (% of total expenses) in Subsidies and Transfers in 2007 and the Expenses (% of total expenses) in Other expenses in 2008?
Your response must be concise. 29.24. What is the difference between the Expenses (% of total expenses) in Compensation of employees in 2007 and the Expenses (% of total expenses) in Goods and services in 2009?
Ensure brevity in your answer.  27.78. What is the difference between the Expenses (% of total expenses) of Compensation of employees in 2007 and the Expenses (% of total expenses) of Subsidies and Transfers in 2009?
Make the answer very short. -4.15. What is the difference between the Expenses (% of total expenses) in Compensation of employees in 2007 and the Expenses (% of total expenses) in Other expenses in 2009?
Provide a short and direct response. 29.73. What is the difference between the Expenses (% of total expenses) in Goods and services in 2007 and the Expenses (% of total expenses) in Subsidies and Transfers in 2009?
Offer a terse response. -32.58. What is the difference between the Expenses (% of total expenses) of Goods and services in 2007 and the Expenses (% of total expenses) of Other expenses in 2009?
Ensure brevity in your answer.  1.3. What is the difference between the Expenses (% of total expenses) in Subsidies and Transfers in 2007 and the Expenses (% of total expenses) in Other expenses in 2009?
Make the answer very short. 28.72. What is the difference between the Expenses (% of total expenses) of Compensation of employees in 2008 and the Expenses (% of total expenses) of Goods and services in 2009?
Your answer should be compact. 28.23. What is the difference between the Expenses (% of total expenses) of Compensation of employees in 2008 and the Expenses (% of total expenses) of Subsidies and Transfers in 2009?
Make the answer very short. -3.7. What is the difference between the Expenses (% of total expenses) of Compensation of employees in 2008 and the Expenses (% of total expenses) of Other expenses in 2009?
Provide a short and direct response. 30.18. What is the difference between the Expenses (% of total expenses) in Goods and services in 2008 and the Expenses (% of total expenses) in Subsidies and Transfers in 2009?
Provide a short and direct response. -33.09. What is the difference between the Expenses (% of total expenses) of Goods and services in 2008 and the Expenses (% of total expenses) of Other expenses in 2009?
Your answer should be compact. 0.79. What is the difference between the Expenses (% of total expenses) in Subsidies and Transfers in 2008 and the Expenses (% of total expenses) in Other expenses in 2009?
Your response must be concise. 30.83. What is the average Expenses (% of total expenses) in Compensation of employees per year?
Keep it short and to the point. 39.89. What is the average Expenses (% of total expenses) of Goods and services per year?
Offer a terse response. 7.78. What is the average Expenses (% of total expenses) in Subsidies and Transfers per year?
Offer a very short reply. 33.92. What is the average Expenses (% of total expenses) in Other expenses per year?
Provide a short and direct response. 8.52. In the year 2002, what is the difference between the Expenses (% of total expenses) of Compensation of employees and Expenses (% of total expenses) of Goods and services?
Your answer should be compact. 33.35. In the year 2002, what is the difference between the Expenses (% of total expenses) in Compensation of employees and Expenses (% of total expenses) in Subsidies and Transfers?
Keep it short and to the point. 13.83. In the year 2002, what is the difference between the Expenses (% of total expenses) of Compensation of employees and Expenses (% of total expenses) of Other expenses?
Provide a succinct answer. 32.81. In the year 2002, what is the difference between the Expenses (% of total expenses) of Goods and services and Expenses (% of total expenses) of Subsidies and Transfers?
Give a very brief answer. -19.52. In the year 2002, what is the difference between the Expenses (% of total expenses) in Goods and services and Expenses (% of total expenses) in Other expenses?
Provide a short and direct response. -0.55. In the year 2002, what is the difference between the Expenses (% of total expenses) of Subsidies and Transfers and Expenses (% of total expenses) of Other expenses?
Your answer should be compact. 18.98. In the year 2003, what is the difference between the Expenses (% of total expenses) of Compensation of employees and Expenses (% of total expenses) of Goods and services?
Your answer should be very brief. 36.95. In the year 2003, what is the difference between the Expenses (% of total expenses) of Compensation of employees and Expenses (% of total expenses) of Subsidies and Transfers?
Offer a terse response. 13.27. In the year 2003, what is the difference between the Expenses (% of total expenses) in Compensation of employees and Expenses (% of total expenses) in Other expenses?
Ensure brevity in your answer.  33.77. In the year 2003, what is the difference between the Expenses (% of total expenses) of Goods and services and Expenses (% of total expenses) of Subsidies and Transfers?
Make the answer very short. -23.68. In the year 2003, what is the difference between the Expenses (% of total expenses) in Goods and services and Expenses (% of total expenses) in Other expenses?
Keep it short and to the point. -3.18. In the year 2003, what is the difference between the Expenses (% of total expenses) in Subsidies and Transfers and Expenses (% of total expenses) in Other expenses?
Give a very brief answer. 20.5. In the year 2004, what is the difference between the Expenses (% of total expenses) in Compensation of employees and Expenses (% of total expenses) in Goods and services?
Your response must be concise. 36.88. In the year 2004, what is the difference between the Expenses (% of total expenses) of Compensation of employees and Expenses (% of total expenses) of Subsidies and Transfers?
Your answer should be very brief. 12.15. In the year 2004, what is the difference between the Expenses (% of total expenses) of Compensation of employees and Expenses (% of total expenses) of Other expenses?
Your answer should be very brief. 35.04. In the year 2004, what is the difference between the Expenses (% of total expenses) of Goods and services and Expenses (% of total expenses) of Subsidies and Transfers?
Your answer should be compact. -24.73. In the year 2004, what is the difference between the Expenses (% of total expenses) of Goods and services and Expenses (% of total expenses) of Other expenses?
Your answer should be compact. -1.84. In the year 2004, what is the difference between the Expenses (% of total expenses) in Subsidies and Transfers and Expenses (% of total expenses) in Other expenses?
Your response must be concise. 22.89. In the year 2005, what is the difference between the Expenses (% of total expenses) in Compensation of employees and Expenses (% of total expenses) in Goods and services?
Your response must be concise. 31.64. In the year 2005, what is the difference between the Expenses (% of total expenses) of Compensation of employees and Expenses (% of total expenses) of Subsidies and Transfers?
Ensure brevity in your answer.  9.53. In the year 2005, what is the difference between the Expenses (% of total expenses) of Compensation of employees and Expenses (% of total expenses) of Other expenses?
Make the answer very short. 29.26. In the year 2005, what is the difference between the Expenses (% of total expenses) of Goods and services and Expenses (% of total expenses) of Subsidies and Transfers?
Give a very brief answer. -22.11. In the year 2005, what is the difference between the Expenses (% of total expenses) of Goods and services and Expenses (% of total expenses) of Other expenses?
Provide a short and direct response. -2.39. In the year 2005, what is the difference between the Expenses (% of total expenses) of Subsidies and Transfers and Expenses (% of total expenses) of Other expenses?
Offer a very short reply. 19.73. In the year 2006, what is the difference between the Expenses (% of total expenses) in Compensation of employees and Expenses (% of total expenses) in Goods and services?
Give a very brief answer. 31.37. In the year 2006, what is the difference between the Expenses (% of total expenses) in Compensation of employees and Expenses (% of total expenses) in Subsidies and Transfers?
Your response must be concise. 1.68. In the year 2006, what is the difference between the Expenses (% of total expenses) of Compensation of employees and Expenses (% of total expenses) of Other expenses?
Offer a very short reply. 31.02. In the year 2006, what is the difference between the Expenses (% of total expenses) in Goods and services and Expenses (% of total expenses) in Subsidies and Transfers?
Your response must be concise. -29.69. In the year 2006, what is the difference between the Expenses (% of total expenses) in Goods and services and Expenses (% of total expenses) in Other expenses?
Ensure brevity in your answer.  -0.35. In the year 2006, what is the difference between the Expenses (% of total expenses) of Subsidies and Transfers and Expenses (% of total expenses) of Other expenses?
Provide a succinct answer. 29.33. In the year 2007, what is the difference between the Expenses (% of total expenses) of Compensation of employees and Expenses (% of total expenses) of Goods and services?
Your response must be concise. 28.43. In the year 2007, what is the difference between the Expenses (% of total expenses) in Compensation of employees and Expenses (% of total expenses) in Subsidies and Transfers?
Your answer should be compact. 1.01. In the year 2007, what is the difference between the Expenses (% of total expenses) in Compensation of employees and Expenses (% of total expenses) in Other expenses?
Your answer should be compact. 27.57. In the year 2007, what is the difference between the Expenses (% of total expenses) in Goods and services and Expenses (% of total expenses) in Subsidies and Transfers?
Your answer should be compact. -27.43. In the year 2007, what is the difference between the Expenses (% of total expenses) of Goods and services and Expenses (% of total expenses) of Other expenses?
Keep it short and to the point. -0.87. In the year 2007, what is the difference between the Expenses (% of total expenses) in Subsidies and Transfers and Expenses (% of total expenses) in Other expenses?
Your answer should be compact. 26.56. In the year 2008, what is the difference between the Expenses (% of total expenses) in Compensation of employees and Expenses (% of total expenses) in Goods and services?
Offer a very short reply. 29.39. In the year 2008, what is the difference between the Expenses (% of total expenses) in Compensation of employees and Expenses (% of total expenses) in Subsidies and Transfers?
Make the answer very short. -0.65. In the year 2008, what is the difference between the Expenses (% of total expenses) of Compensation of employees and Expenses (% of total expenses) of Other expenses?
Provide a succinct answer. 30.7. In the year 2008, what is the difference between the Expenses (% of total expenses) in Goods and services and Expenses (% of total expenses) in Subsidies and Transfers?
Keep it short and to the point. -30.04. In the year 2008, what is the difference between the Expenses (% of total expenses) of Goods and services and Expenses (% of total expenses) of Other expenses?
Provide a short and direct response. 1.31. In the year 2008, what is the difference between the Expenses (% of total expenses) of Subsidies and Transfers and Expenses (% of total expenses) of Other expenses?
Your answer should be very brief. 31.35. In the year 2009, what is the difference between the Expenses (% of total expenses) in Compensation of employees and Expenses (% of total expenses) in Goods and services?
Your response must be concise. 28.88. In the year 2009, what is the difference between the Expenses (% of total expenses) in Compensation of employees and Expenses (% of total expenses) in Subsidies and Transfers?
Provide a succinct answer. -3.05. In the year 2009, what is the difference between the Expenses (% of total expenses) of Compensation of employees and Expenses (% of total expenses) of Other expenses?
Ensure brevity in your answer.  30.83. In the year 2009, what is the difference between the Expenses (% of total expenses) of Goods and services and Expenses (% of total expenses) of Subsidies and Transfers?
Offer a very short reply. -31.93. In the year 2009, what is the difference between the Expenses (% of total expenses) in Goods and services and Expenses (% of total expenses) in Other expenses?
Your answer should be very brief. 1.96. In the year 2009, what is the difference between the Expenses (% of total expenses) in Subsidies and Transfers and Expenses (% of total expenses) in Other expenses?
Keep it short and to the point. 33.88. What is the ratio of the Expenses (% of total expenses) in Compensation of employees in 2002 to that in 2003?
Provide a short and direct response. 0.94. What is the ratio of the Expenses (% of total expenses) in Goods and services in 2002 to that in 2003?
Your answer should be very brief. 1.1. What is the ratio of the Expenses (% of total expenses) of Subsidies and Transfers in 2002 to that in 2003?
Provide a succinct answer. 0.89. What is the ratio of the Expenses (% of total expenses) in Other expenses in 2002 to that in 2003?
Provide a succinct answer. 0.83. What is the ratio of the Expenses (% of total expenses) of Compensation of employees in 2002 to that in 2004?
Offer a terse response. 0.94. What is the ratio of the Expenses (% of total expenses) of Goods and services in 2002 to that in 2004?
Your response must be concise. 1.12. What is the ratio of the Expenses (% of total expenses) of Subsidies and Transfers in 2002 to that in 2004?
Provide a short and direct response. 0.87. What is the ratio of the Expenses (% of total expenses) of Other expenses in 2002 to that in 2004?
Your answer should be compact. 0.96. What is the ratio of the Expenses (% of total expenses) of Compensation of employees in 2002 to that in 2005?
Provide a short and direct response. 1.06. What is the ratio of the Expenses (% of total expenses) in Goods and services in 2002 to that in 2005?
Offer a terse response. 1.09. What is the ratio of the Expenses (% of total expenses) in Subsidies and Transfers in 2002 to that in 2005?
Your answer should be compact. 0.94. What is the ratio of the Expenses (% of total expenses) of Other expenses in 2002 to that in 2005?
Your answer should be compact. 0.88. What is the ratio of the Expenses (% of total expenses) in Compensation of employees in 2002 to that in 2006?
Offer a very short reply. 1.09. What is the ratio of the Expenses (% of total expenses) in Goods and services in 2002 to that in 2006?
Your answer should be very brief. 1.18. What is the ratio of the Expenses (% of total expenses) in Subsidies and Transfers in 2002 to that in 2006?
Ensure brevity in your answer.  0.76. What is the ratio of the Expenses (% of total expenses) in Other expenses in 2002 to that in 2006?
Give a very brief answer. 1.2. What is the ratio of the Expenses (% of total expenses) in Compensation of employees in 2002 to that in 2007?
Make the answer very short. 1.15. What is the ratio of the Expenses (% of total expenses) in Goods and services in 2002 to that in 2007?
Keep it short and to the point. 1.08. What is the ratio of the Expenses (% of total expenses) of Subsidies and Transfers in 2002 to that in 2007?
Provide a short and direct response. 0.79. What is the ratio of the Expenses (% of total expenses) of Other expenses in 2002 to that in 2007?
Your answer should be very brief. 1.03. What is the ratio of the Expenses (% of total expenses) in Compensation of employees in 2002 to that in 2008?
Your answer should be very brief. 1.14. What is the ratio of the Expenses (% of total expenses) in Goods and services in 2002 to that in 2008?
Your answer should be compact. 1.15. What is the ratio of the Expenses (% of total expenses) of Subsidies and Transfers in 2002 to that in 2008?
Offer a very short reply. 0.75. What is the ratio of the Expenses (% of total expenses) in Other expenses in 2002 to that in 2008?
Provide a succinct answer. 1.49. What is the ratio of the Expenses (% of total expenses) of Compensation of employees in 2002 to that in 2009?
Give a very brief answer. 1.12. What is the ratio of the Expenses (% of total expenses) in Subsidies and Transfers in 2002 to that in 2009?
Your response must be concise. 0.69. What is the ratio of the Expenses (% of total expenses) in Other expenses in 2002 to that in 2009?
Your answer should be compact. 1.37. What is the ratio of the Expenses (% of total expenses) of Goods and services in 2003 to that in 2004?
Offer a very short reply. 1.02. What is the ratio of the Expenses (% of total expenses) of Subsidies and Transfers in 2003 to that in 2004?
Provide a short and direct response. 0.97. What is the ratio of the Expenses (% of total expenses) in Other expenses in 2003 to that in 2004?
Ensure brevity in your answer.  1.16. What is the ratio of the Expenses (% of total expenses) of Compensation of employees in 2003 to that in 2005?
Your response must be concise. 1.13. What is the ratio of the Expenses (% of total expenses) of Goods and services in 2003 to that in 2005?
Give a very brief answer. 0.99. What is the ratio of the Expenses (% of total expenses) in Subsidies and Transfers in 2003 to that in 2005?
Ensure brevity in your answer.  1.05. What is the ratio of the Expenses (% of total expenses) in Other expenses in 2003 to that in 2005?
Give a very brief answer. 1.07. What is the ratio of the Expenses (% of total expenses) of Compensation of employees in 2003 to that in 2006?
Your answer should be very brief. 1.16. What is the ratio of the Expenses (% of total expenses) of Goods and services in 2003 to that in 2006?
Offer a very short reply. 1.08. What is the ratio of the Expenses (% of total expenses) in Subsidies and Transfers in 2003 to that in 2006?
Ensure brevity in your answer.  0.85. What is the ratio of the Expenses (% of total expenses) in Other expenses in 2003 to that in 2006?
Your answer should be compact. 1.45. What is the ratio of the Expenses (% of total expenses) in Compensation of employees in 2003 to that in 2007?
Offer a very short reply. 1.23. What is the ratio of the Expenses (% of total expenses) in Goods and services in 2003 to that in 2007?
Offer a very short reply. 0.98. What is the ratio of the Expenses (% of total expenses) in Subsidies and Transfers in 2003 to that in 2007?
Offer a very short reply. 0.89. What is the ratio of the Expenses (% of total expenses) of Other expenses in 2003 to that in 2007?
Your answer should be compact. 1.25. What is the ratio of the Expenses (% of total expenses) of Compensation of employees in 2003 to that in 2008?
Your answer should be compact. 1.22. What is the ratio of the Expenses (% of total expenses) in Goods and services in 2003 to that in 2008?
Make the answer very short. 1.05. What is the ratio of the Expenses (% of total expenses) of Subsidies and Transfers in 2003 to that in 2008?
Offer a very short reply. 0.84. What is the ratio of the Expenses (% of total expenses) in Other expenses in 2003 to that in 2008?
Keep it short and to the point. 1.8. What is the ratio of the Expenses (% of total expenses) in Compensation of employees in 2003 to that in 2009?
Your response must be concise. 1.19. What is the ratio of the Expenses (% of total expenses) in Goods and services in 2003 to that in 2009?
Provide a succinct answer. 0.9. What is the ratio of the Expenses (% of total expenses) of Subsidies and Transfers in 2003 to that in 2009?
Make the answer very short. 0.78. What is the ratio of the Expenses (% of total expenses) of Other expenses in 2003 to that in 2009?
Provide a succinct answer. 1.66. What is the ratio of the Expenses (% of total expenses) in Compensation of employees in 2004 to that in 2005?
Make the answer very short. 1.13. What is the ratio of the Expenses (% of total expenses) in Goods and services in 2004 to that in 2005?
Make the answer very short. 0.97. What is the ratio of the Expenses (% of total expenses) of Subsidies and Transfers in 2004 to that in 2005?
Your answer should be compact. 1.08. What is the ratio of the Expenses (% of total expenses) in Other expenses in 2004 to that in 2005?
Your response must be concise. 0.92. What is the ratio of the Expenses (% of total expenses) of Compensation of employees in 2004 to that in 2006?
Your answer should be very brief. 1.15. What is the ratio of the Expenses (% of total expenses) in Goods and services in 2004 to that in 2006?
Provide a succinct answer. 1.06. What is the ratio of the Expenses (% of total expenses) of Subsidies and Transfers in 2004 to that in 2006?
Ensure brevity in your answer.  0.88. What is the ratio of the Expenses (% of total expenses) in Other expenses in 2004 to that in 2006?
Make the answer very short. 1.25. What is the ratio of the Expenses (% of total expenses) of Compensation of employees in 2004 to that in 2007?
Offer a terse response. 1.22. What is the ratio of the Expenses (% of total expenses) of Goods and services in 2004 to that in 2007?
Provide a short and direct response. 0.96. What is the ratio of the Expenses (% of total expenses) in Subsidies and Transfers in 2004 to that in 2007?
Your answer should be very brief. 0.92. What is the ratio of the Expenses (% of total expenses) in Other expenses in 2004 to that in 2007?
Provide a succinct answer. 1.08. What is the ratio of the Expenses (% of total expenses) in Compensation of employees in 2004 to that in 2008?
Provide a short and direct response. 1.21. What is the ratio of the Expenses (% of total expenses) in Goods and services in 2004 to that in 2008?
Your answer should be compact. 1.03. What is the ratio of the Expenses (% of total expenses) of Subsidies and Transfers in 2004 to that in 2008?
Your answer should be very brief. 0.86. What is the ratio of the Expenses (% of total expenses) of Other expenses in 2004 to that in 2008?
Offer a terse response. 1.56. What is the ratio of the Expenses (% of total expenses) in Compensation of employees in 2004 to that in 2009?
Provide a short and direct response. 1.19. What is the ratio of the Expenses (% of total expenses) of Goods and services in 2004 to that in 2009?
Offer a very short reply. 0.89. What is the ratio of the Expenses (% of total expenses) of Subsidies and Transfers in 2004 to that in 2009?
Offer a terse response. 0.8. What is the ratio of the Expenses (% of total expenses) of Other expenses in 2004 to that in 2009?
Offer a very short reply. 1.43. What is the ratio of the Expenses (% of total expenses) in Compensation of employees in 2005 to that in 2006?
Offer a very short reply. 1.02. What is the ratio of the Expenses (% of total expenses) of Goods and services in 2005 to that in 2006?
Offer a very short reply. 1.09. What is the ratio of the Expenses (% of total expenses) in Subsidies and Transfers in 2005 to that in 2006?
Your answer should be compact. 0.81. What is the ratio of the Expenses (% of total expenses) of Other expenses in 2005 to that in 2006?
Your answer should be very brief. 1.36. What is the ratio of the Expenses (% of total expenses) of Compensation of employees in 2005 to that in 2007?
Provide a succinct answer. 1.09. What is the ratio of the Expenses (% of total expenses) in Subsidies and Transfers in 2005 to that in 2007?
Keep it short and to the point. 0.85. What is the ratio of the Expenses (% of total expenses) in Other expenses in 2005 to that in 2007?
Make the answer very short. 1.17. What is the ratio of the Expenses (% of total expenses) in Compensation of employees in 2005 to that in 2008?
Make the answer very short. 1.07. What is the ratio of the Expenses (% of total expenses) in Goods and services in 2005 to that in 2008?
Give a very brief answer. 1.06. What is the ratio of the Expenses (% of total expenses) of Subsidies and Transfers in 2005 to that in 2008?
Your answer should be compact. 0.8. What is the ratio of the Expenses (% of total expenses) of Other expenses in 2005 to that in 2008?
Your answer should be compact. 1.69. What is the ratio of the Expenses (% of total expenses) of Compensation of employees in 2005 to that in 2009?
Ensure brevity in your answer.  1.05. What is the ratio of the Expenses (% of total expenses) of Goods and services in 2005 to that in 2009?
Provide a short and direct response. 0.92. What is the ratio of the Expenses (% of total expenses) in Subsidies and Transfers in 2005 to that in 2009?
Provide a succinct answer. 0.74. What is the ratio of the Expenses (% of total expenses) of Other expenses in 2005 to that in 2009?
Keep it short and to the point. 1.55. What is the ratio of the Expenses (% of total expenses) of Compensation of employees in 2006 to that in 2007?
Offer a terse response. 1.06. What is the ratio of the Expenses (% of total expenses) of Goods and services in 2006 to that in 2007?
Offer a very short reply. 0.91. What is the ratio of the Expenses (% of total expenses) in Subsidies and Transfers in 2006 to that in 2007?
Your response must be concise. 1.04. What is the ratio of the Expenses (% of total expenses) in Other expenses in 2006 to that in 2007?
Ensure brevity in your answer.  0.86. What is the ratio of the Expenses (% of total expenses) in Compensation of employees in 2006 to that in 2008?
Offer a terse response. 1.05. What is the ratio of the Expenses (% of total expenses) of Goods and services in 2006 to that in 2008?
Give a very brief answer. 0.97. What is the ratio of the Expenses (% of total expenses) of Subsidies and Transfers in 2006 to that in 2008?
Your answer should be compact. 0.99. What is the ratio of the Expenses (% of total expenses) of Other expenses in 2006 to that in 2008?
Your answer should be very brief. 1.24. What is the ratio of the Expenses (% of total expenses) in Compensation of employees in 2006 to that in 2009?
Ensure brevity in your answer.  1.03. What is the ratio of the Expenses (% of total expenses) of Goods and services in 2006 to that in 2009?
Keep it short and to the point. 0.84. What is the ratio of the Expenses (% of total expenses) in Subsidies and Transfers in 2006 to that in 2009?
Your answer should be compact. 0.91. What is the ratio of the Expenses (% of total expenses) in Other expenses in 2006 to that in 2009?
Keep it short and to the point. 1.15. What is the ratio of the Expenses (% of total expenses) of Goods and services in 2007 to that in 2008?
Provide a short and direct response. 1.07. What is the ratio of the Expenses (% of total expenses) of Subsidies and Transfers in 2007 to that in 2008?
Keep it short and to the point. 0.94. What is the ratio of the Expenses (% of total expenses) of Other expenses in 2007 to that in 2008?
Ensure brevity in your answer.  1.44. What is the ratio of the Expenses (% of total expenses) in Compensation of employees in 2007 to that in 2009?
Your answer should be compact. 0.97. What is the ratio of the Expenses (% of total expenses) of Goods and services in 2007 to that in 2009?
Offer a very short reply. 0.92. What is the ratio of the Expenses (% of total expenses) in Subsidies and Transfers in 2007 to that in 2009?
Your answer should be very brief. 0.87. What is the ratio of the Expenses (% of total expenses) in Other expenses in 2007 to that in 2009?
Give a very brief answer. 1.33. What is the ratio of the Expenses (% of total expenses) in Compensation of employees in 2008 to that in 2009?
Your response must be concise. 0.98. What is the ratio of the Expenses (% of total expenses) of Goods and services in 2008 to that in 2009?
Provide a short and direct response. 0.86. What is the ratio of the Expenses (% of total expenses) of Subsidies and Transfers in 2008 to that in 2009?
Ensure brevity in your answer.  0.92. What is the ratio of the Expenses (% of total expenses) of Other expenses in 2008 to that in 2009?
Provide a short and direct response. 0.92. What is the difference between the highest and the second highest Expenses (% of total expenses) of Compensation of employees?
Ensure brevity in your answer.  0.22. What is the difference between the highest and the second highest Expenses (% of total expenses) in Goods and services?
Make the answer very short. 0.05. What is the difference between the highest and the second highest Expenses (% of total expenses) of Subsidies and Transfers?
Give a very brief answer. 3.05. What is the difference between the highest and the second highest Expenses (% of total expenses) in Other expenses?
Keep it short and to the point. 0.71. What is the difference between the highest and the lowest Expenses (% of total expenses) in Compensation of employees?
Provide a short and direct response. 8.37. What is the difference between the highest and the lowest Expenses (% of total expenses) in Goods and services?
Offer a very short reply. 1.36. What is the difference between the highest and the lowest Expenses (% of total expenses) of Subsidies and Transfers?
Your response must be concise. 12.46. What is the difference between the highest and the lowest Expenses (% of total expenses) in Other expenses?
Your answer should be very brief. 4.84. 